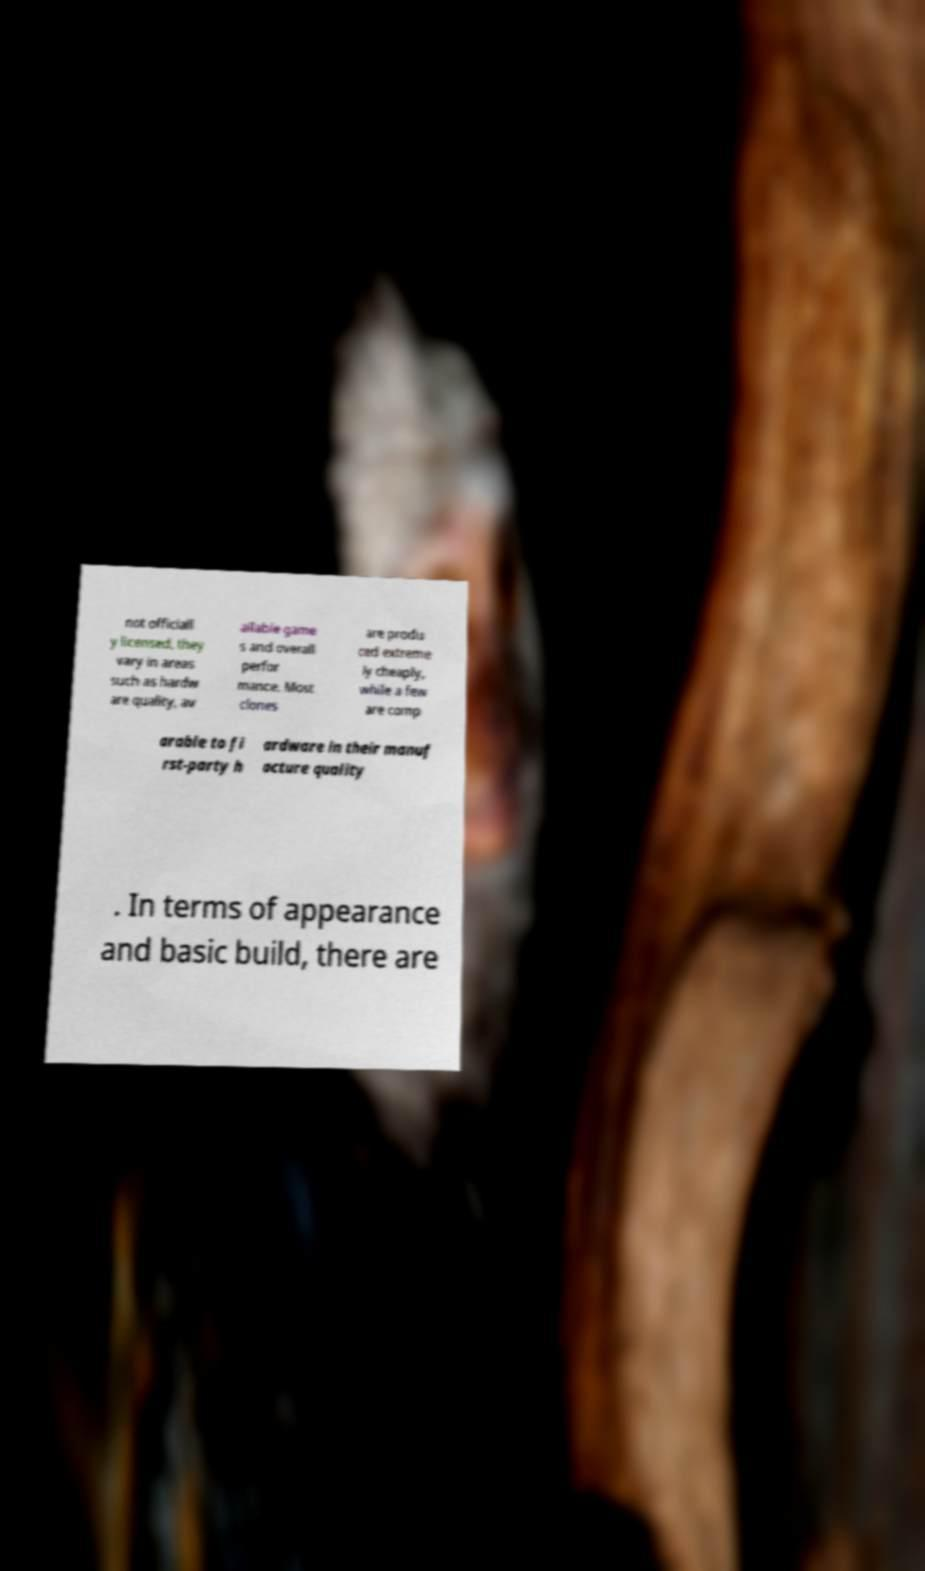Can you accurately transcribe the text from the provided image for me? not officiall y licensed, they vary in areas such as hardw are quality, av ailable game s and overall perfor mance. Most clones are produ ced extreme ly cheaply, while a few are comp arable to fi rst-party h ardware in their manuf acture quality . In terms of appearance and basic build, there are 